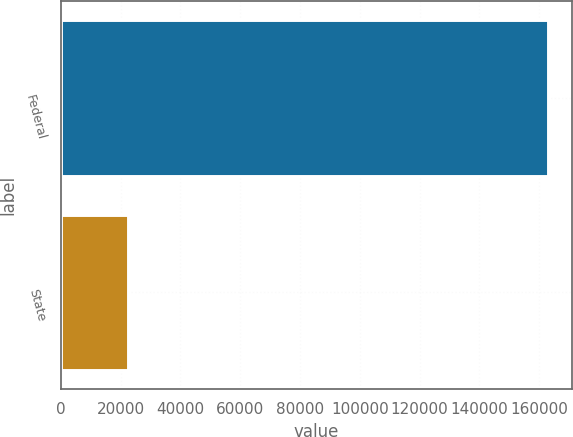Convert chart to OTSL. <chart><loc_0><loc_0><loc_500><loc_500><bar_chart><fcel>Federal<fcel>State<nl><fcel>162891<fcel>22626<nl></chart> 